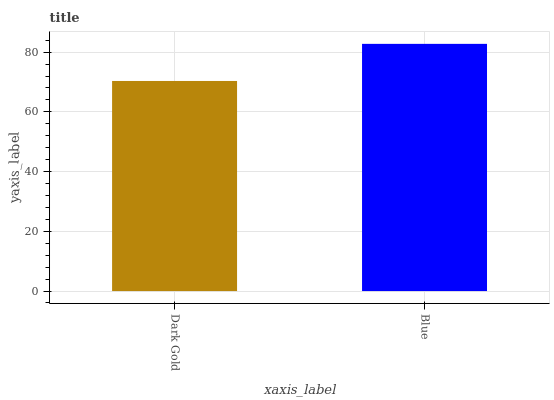Is Dark Gold the minimum?
Answer yes or no. Yes. Is Blue the maximum?
Answer yes or no. Yes. Is Blue the minimum?
Answer yes or no. No. Is Blue greater than Dark Gold?
Answer yes or no. Yes. Is Dark Gold less than Blue?
Answer yes or no. Yes. Is Dark Gold greater than Blue?
Answer yes or no. No. Is Blue less than Dark Gold?
Answer yes or no. No. Is Blue the high median?
Answer yes or no. Yes. Is Dark Gold the low median?
Answer yes or no. Yes. Is Dark Gold the high median?
Answer yes or no. No. Is Blue the low median?
Answer yes or no. No. 